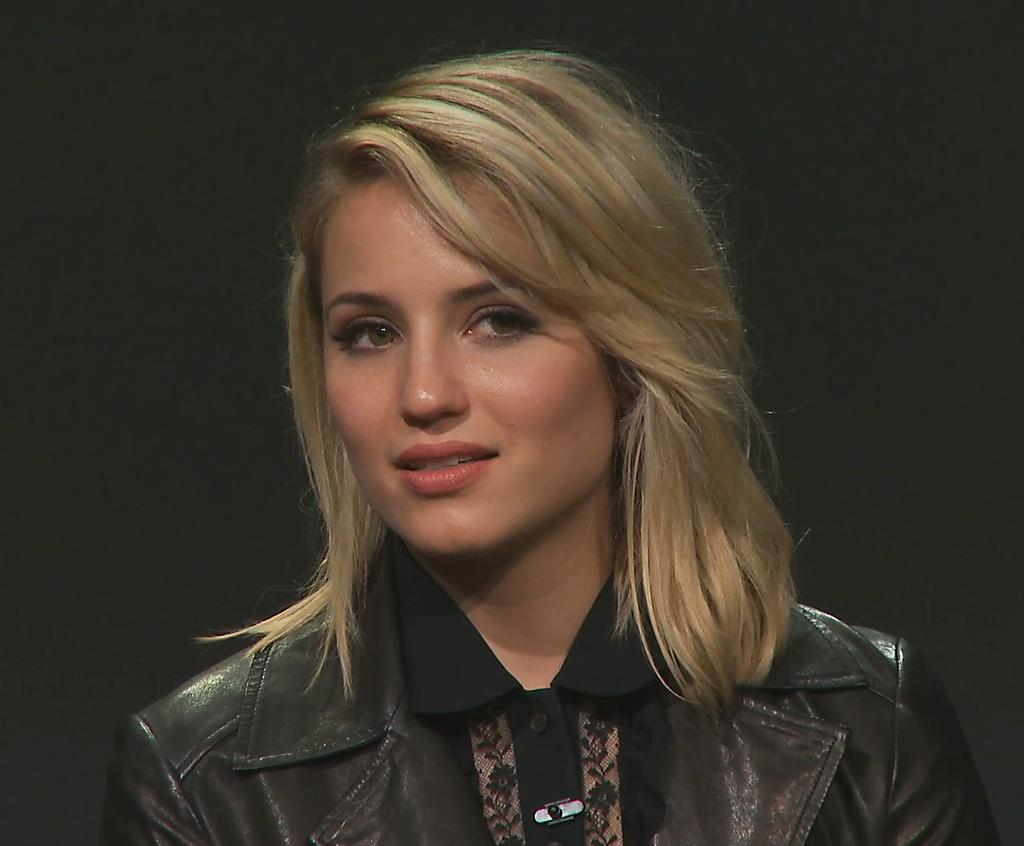Who is the main subject in the image? There is a girl in the image. Where is the girl positioned in the image? The girl is in the center of the image. What type of legal advice is the girl providing in the image? There is no indication in the image that the girl is providing legal advice, as she is not depicted as a lawyer. What type of grass is growing around the girl in the image? There is no grass visible in the image; it is focused solely on the girl. What kind of bubble can be seen surrounding the girl in the image? There is no bubble present in the image; the girl is the main subject without any surrounding bubbles. 